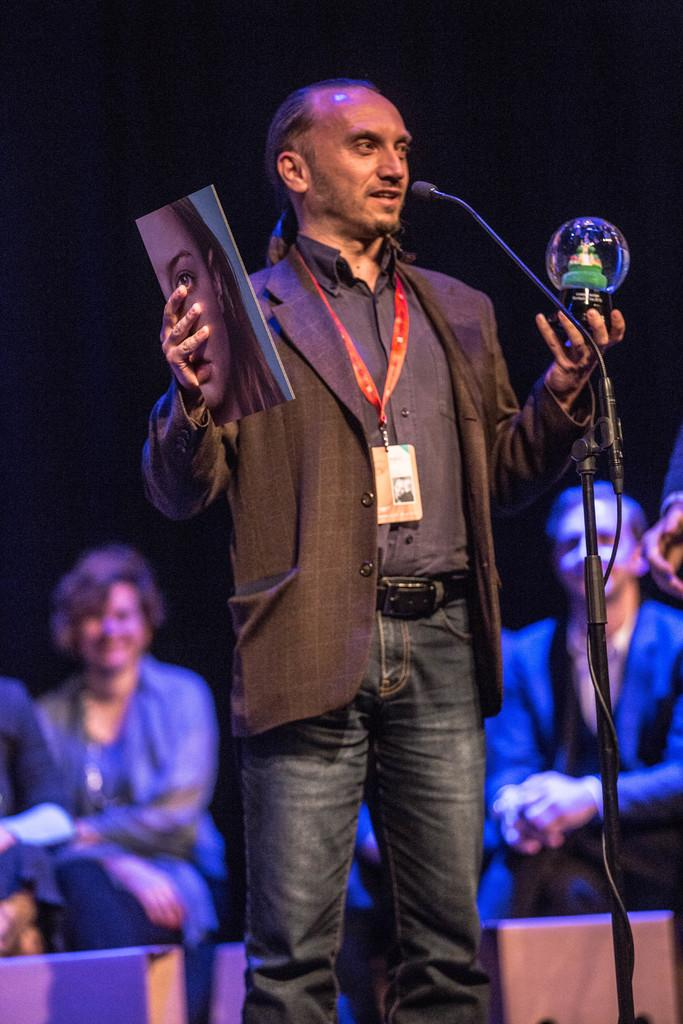What is the main object in the middle of the image? There is a microphone in the middle of the image. Who is standing behind the microphone? A person is standing behind the microphone. What is the person holding in addition to the microphone? The person is holding a toy and a book. Can you describe the people sitting behind the person holding the toy and book? There are people sitting behind the person holding the toy and book. What type of expert advice can be heard from the giraffe in the image? There is no giraffe present in the image, so no expert advice can be heard from a giraffe. 